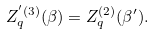<formula> <loc_0><loc_0><loc_500><loc_500>Z _ { q } ^ { ^ { \prime } ( 3 ) } ( \beta ) = Z _ { q } ^ { ( 2 ) } ( \beta ^ { \prime } ) .</formula> 